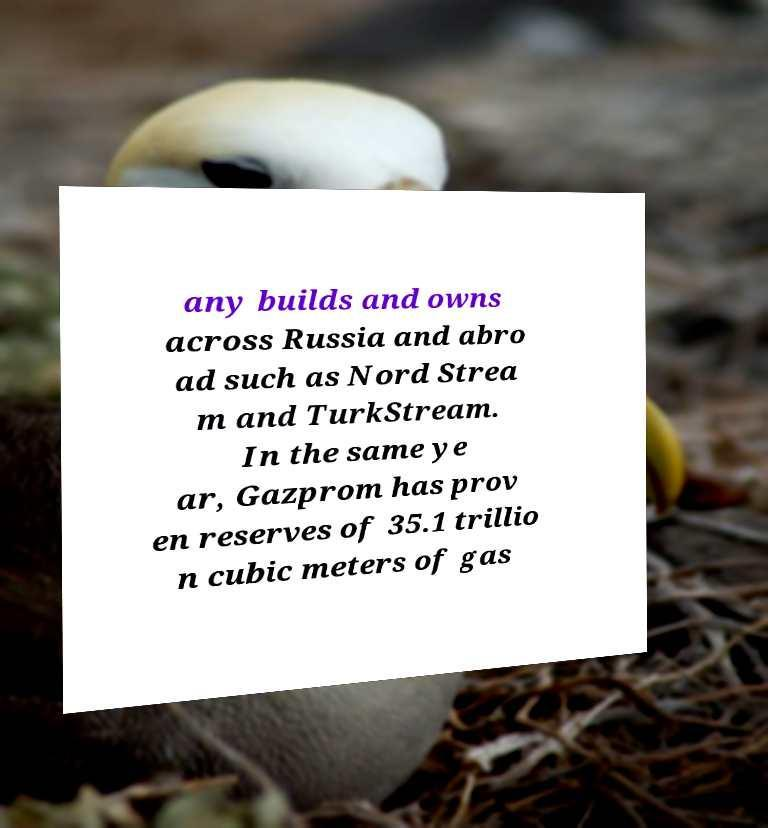Can you accurately transcribe the text from the provided image for me? any builds and owns across Russia and abro ad such as Nord Strea m and TurkStream. In the same ye ar, Gazprom has prov en reserves of 35.1 trillio n cubic meters of gas 